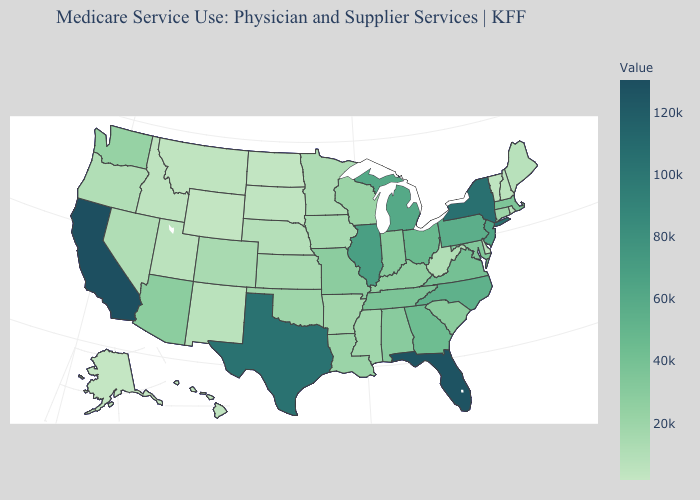Which states have the lowest value in the Northeast?
Short answer required. Vermont. Which states have the lowest value in the South?
Write a very short answer. Delaware. Does California have the highest value in the West?
Keep it brief. Yes. Which states have the lowest value in the USA?
Quick response, please. Alaska. Which states hav the highest value in the West?
Keep it brief. California. Does Virginia have a lower value than Connecticut?
Be succinct. No. Which states hav the highest value in the MidWest?
Answer briefly. Illinois. Does the map have missing data?
Short answer required. No. Among the states that border Utah , which have the highest value?
Be succinct. Arizona. 